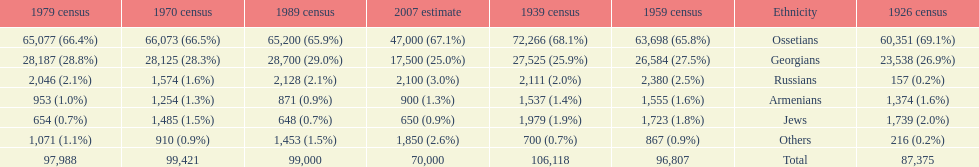Which population had the most people in 1926? Ossetians. 